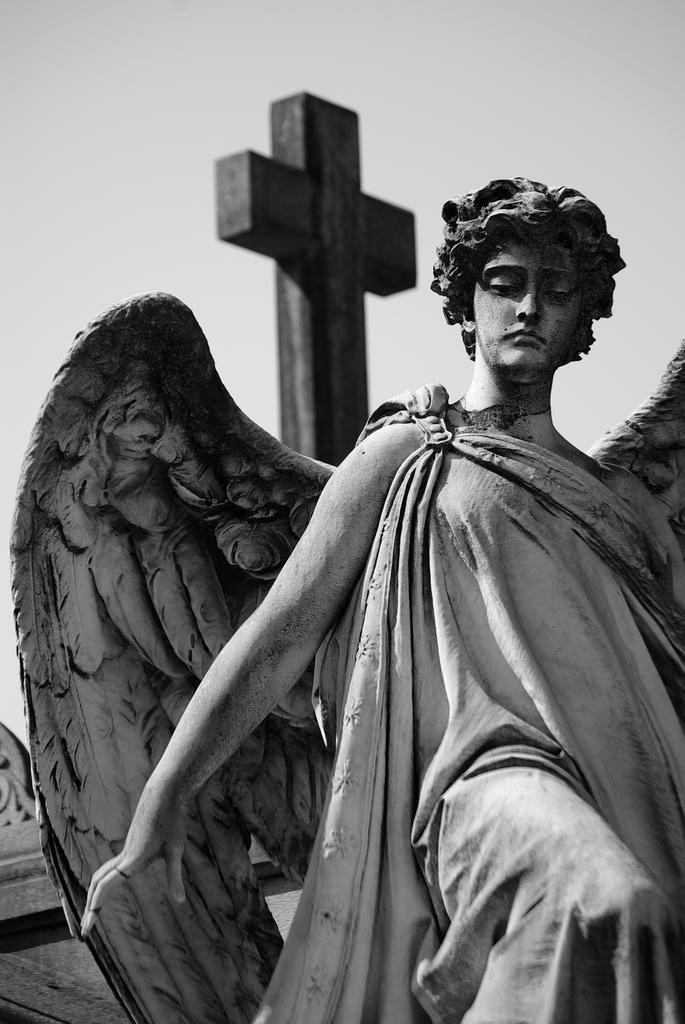What is the color scheme of the image? The image is black and white. What is the main subject in the image? There is a statue in the image. What can be seen in the background of the image? There is a cross in the background of the image. What is visible at the top of the image? The sky is visible at the top of the image. How does the statue provide comfort to the people in the image? The image does not depict people, and there is no indication that the statue provides comfort. 